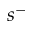Convert formula to latex. <formula><loc_0><loc_0><loc_500><loc_500>s ^ { - }</formula> 